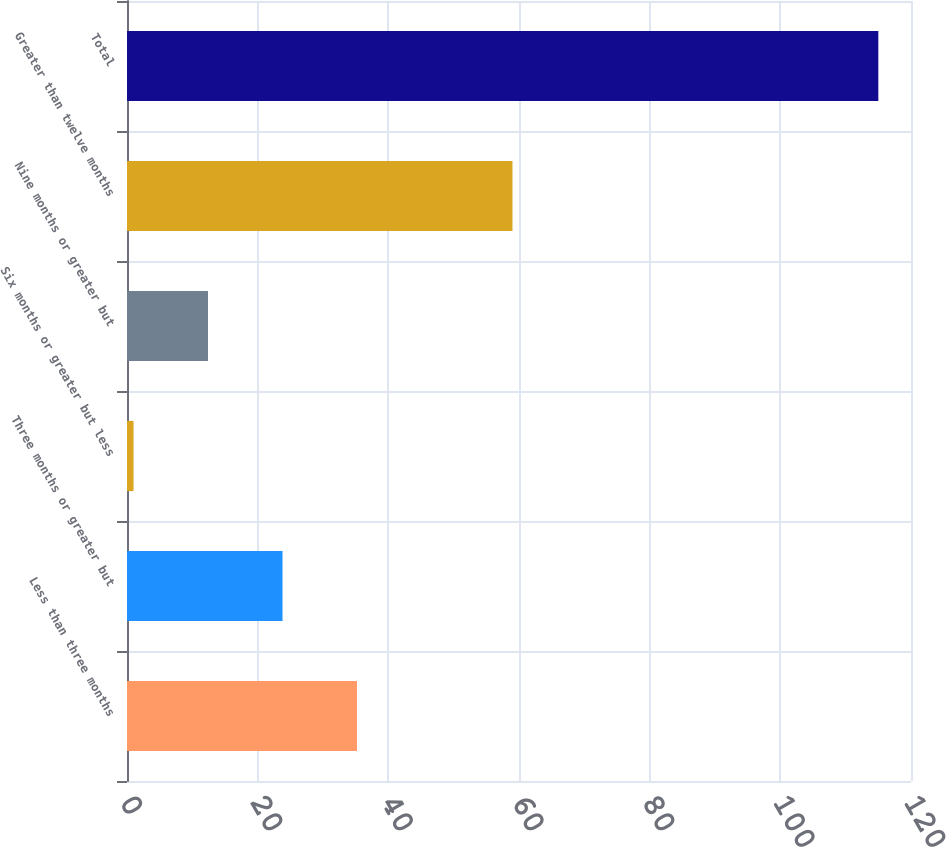Convert chart. <chart><loc_0><loc_0><loc_500><loc_500><bar_chart><fcel>Less than three months<fcel>Three months or greater but<fcel>Six months or greater but less<fcel>Nine months or greater but<fcel>Greater than twelve months<fcel>Total<nl><fcel>35.2<fcel>23.8<fcel>1<fcel>12.4<fcel>59<fcel>115<nl></chart> 